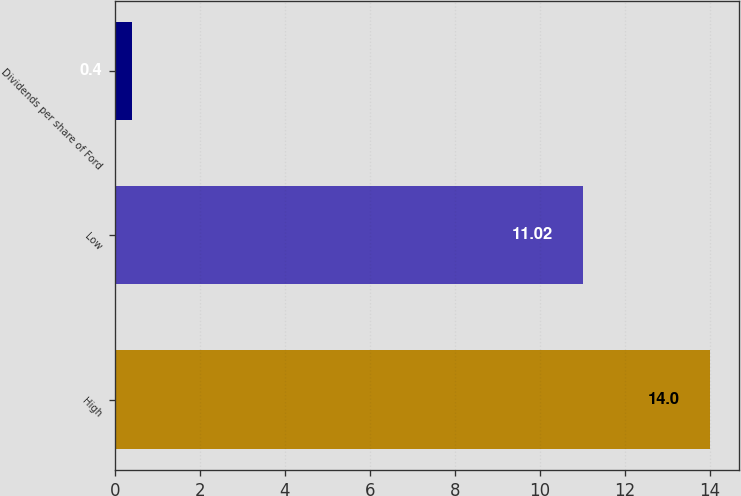<chart> <loc_0><loc_0><loc_500><loc_500><bar_chart><fcel>High<fcel>Low<fcel>Dividends per share of Ford<nl><fcel>14<fcel>11.02<fcel>0.4<nl></chart> 